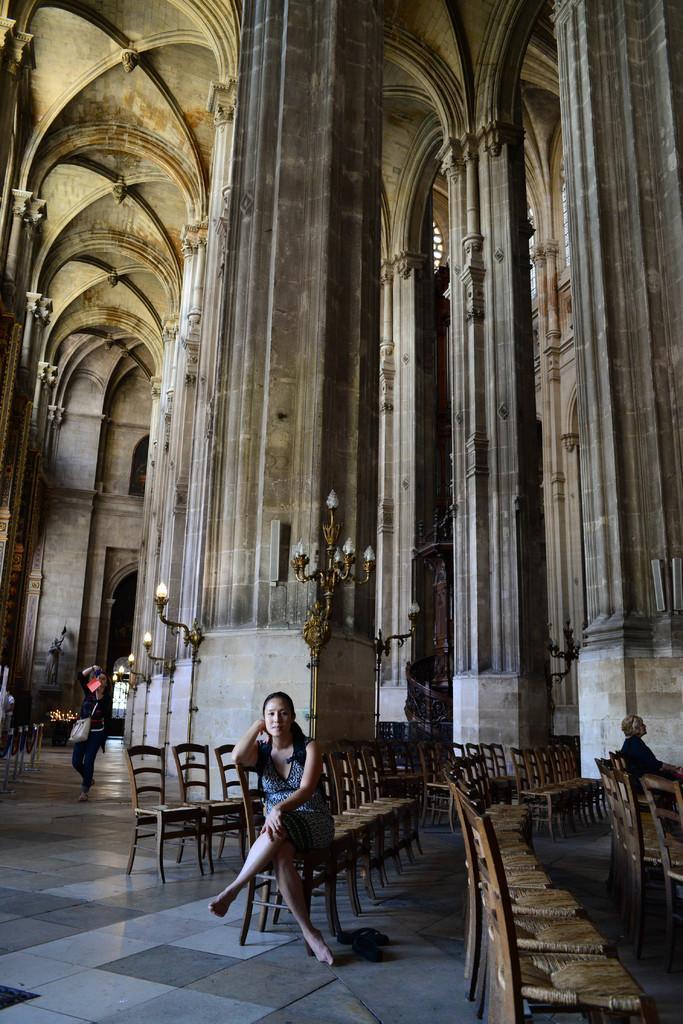Can you describe this image briefly? In this picture we can see a woman who is sitting on the chair. This is floor. On the background there is a wall and these are the lights. 